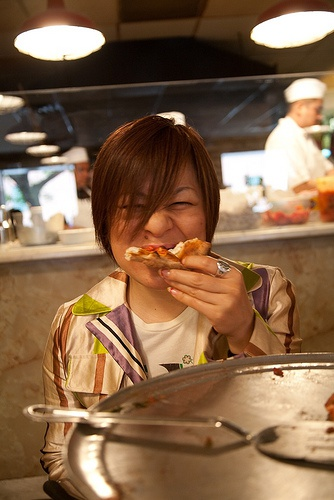Describe the objects in this image and their specific colors. I can see people in maroon, brown, black, and tan tones, people in maroon, ivory, and tan tones, pizza in maroon, brown, red, and orange tones, and people in maroon, brown, and tan tones in this image. 